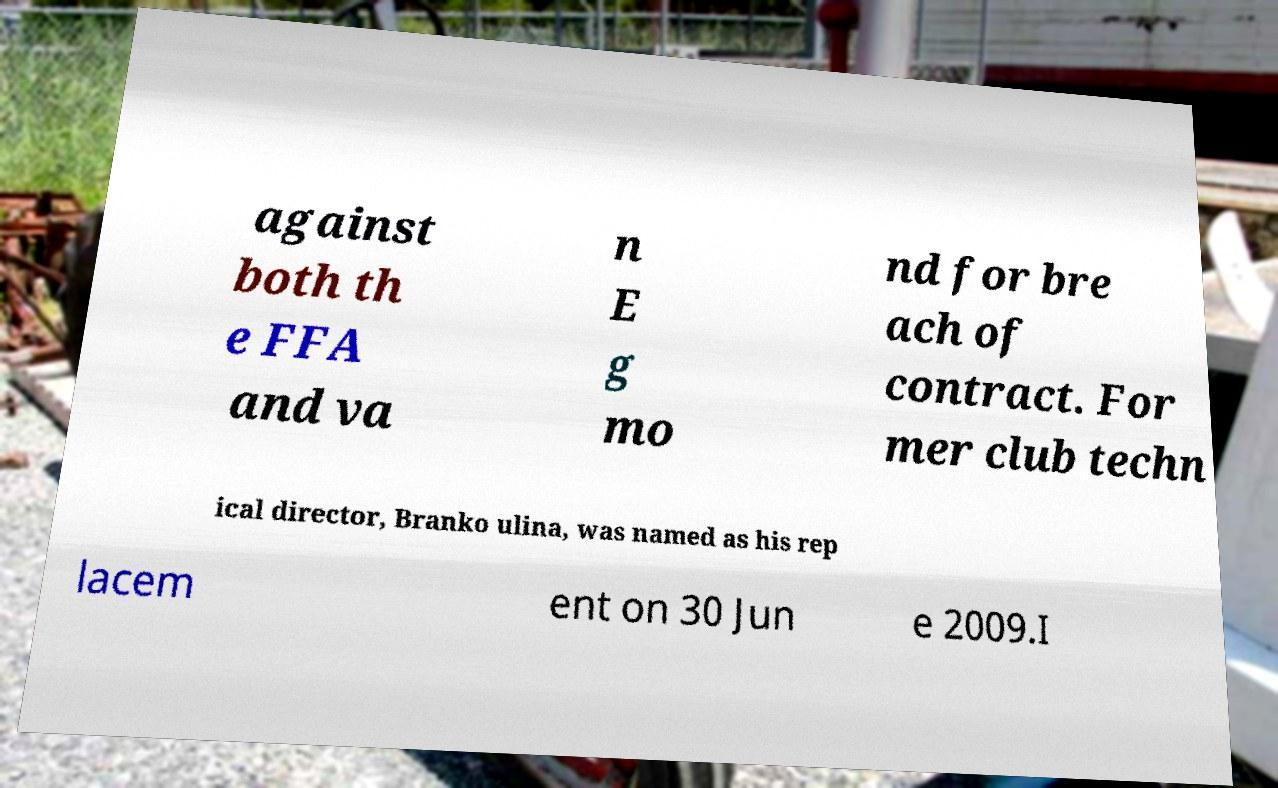Please identify and transcribe the text found in this image. against both th e FFA and va n E g mo nd for bre ach of contract. For mer club techn ical director, Branko ulina, was named as his rep lacem ent on 30 Jun e 2009.I 